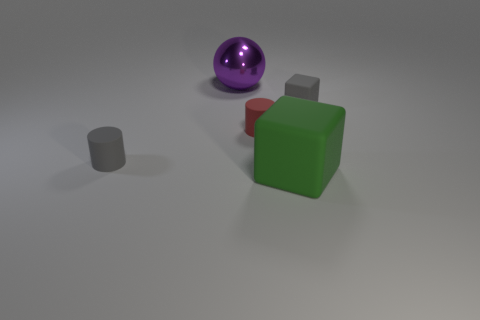Add 5 purple objects. How many objects exist? 10 Subtract all balls. How many objects are left? 4 Add 3 gray rubber spheres. How many gray rubber spheres exist? 3 Subtract 0 yellow blocks. How many objects are left? 5 Subtract all purple matte cylinders. Subtract all large green things. How many objects are left? 4 Add 1 big things. How many big things are left? 3 